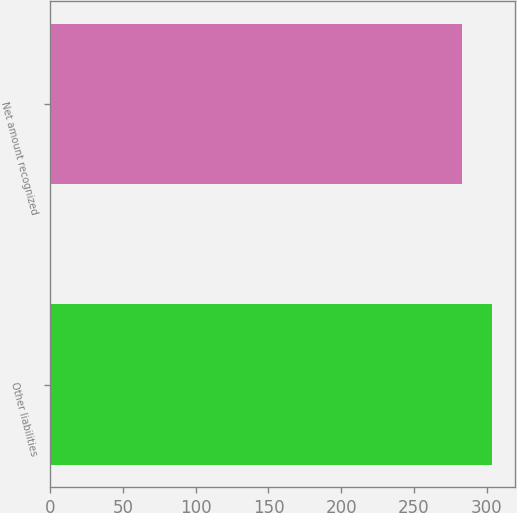Convert chart. <chart><loc_0><loc_0><loc_500><loc_500><bar_chart><fcel>Other liabilities<fcel>Net amount recognized<nl><fcel>304.1<fcel>283.4<nl></chart> 